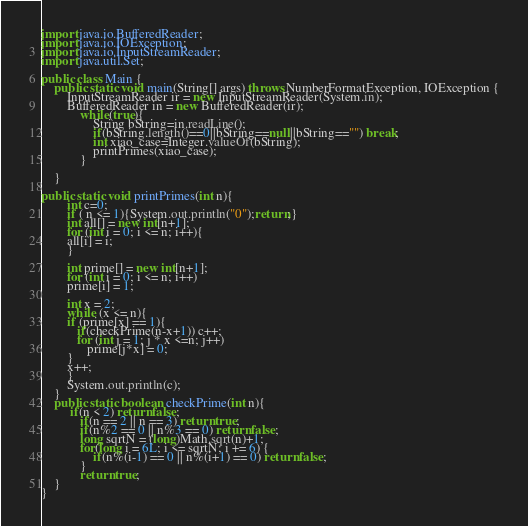Convert code to text. <code><loc_0><loc_0><loc_500><loc_500><_Java_>import java.io.BufferedReader;
import java.io.IOException;
import java.io.InputStreamReader;
import java.util.Set;

public class Main {
    public static void main(String[] args) throws NumberFormatException, IOException {
    	InputStreamReader ir = new InputStreamReader(System.in);
        BufferedReader in = new BufferedReader(ir);
			while(true){
				String bString=in.readLine();
				if(bString.length()==0||bString==null||bString=="") break;
				int xiao_case=Integer.valueOf(bString);
				printPrimes(xiao_case);
			}
    	
	}

public static void printPrimes(int n){
    	int c=0;
    	if ( n <= 1){System.out.println("0");return;}
    	int all[] = new int[n+1];
    	for (int i = 0; i <= n; i++){
    	all[i] = i;
    	}

    	int prime[] = new int[n+1];
    	for (int i = 0; i <= n; i++)
    	prime[i] = 1;

    	int x = 2;
    	while (x <= n){
    	if (prime[x] == 1){
    	   if(checkPrime(n-x+1)) c++;
    	   for (int j = 1; j * x <=n; j++)
    	      prime[j*x] = 0;
    	}
    	x++;
    	}
    	System.out.println(c);
    } 
    public static boolean checkPrime(int n){
    	 if(n < 2) return false;
    	    if(n == 2 || n == 3) return true;
    	    if(n%2 == 0 || n%3 == 0) return false;
    	    long sqrtN = (long)Math.sqrt(n)+1;
    	    for(long i = 6L; i <= sqrtN; i += 6) {
    	        if(n%(i-1) == 0 || n%(i+1) == 0) return false;
    	    }
    	    return true;
    }
}</code> 